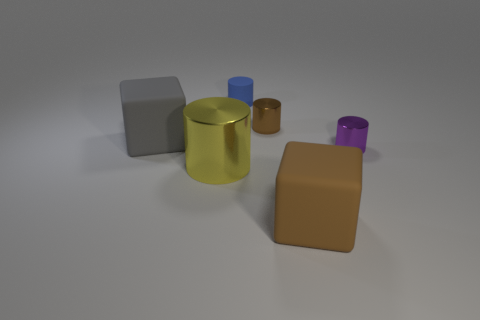Do the small rubber cylinder and the large metal thing have the same color?
Offer a very short reply. No. The metal cylinder that is both right of the tiny blue matte object and on the left side of the purple cylinder is what color?
Your answer should be compact. Brown. How many objects are either small cylinders on the right side of the small blue thing or red shiny spheres?
Offer a very short reply. 2. The matte thing that is the same shape as the yellow shiny thing is what color?
Provide a succinct answer. Blue. Is the shape of the big yellow metallic object the same as the large object that is to the right of the big yellow thing?
Your answer should be compact. No. What number of objects are either big blocks on the right side of the blue rubber object or matte objects that are on the left side of the yellow thing?
Your answer should be very brief. 2. Is the number of brown shiny cylinders right of the large brown thing less than the number of big metal things?
Give a very brief answer. Yes. Is the material of the brown cylinder the same as the tiny cylinder in front of the gray rubber cube?
Your answer should be very brief. Yes. What is the small purple thing made of?
Ensure brevity in your answer.  Metal. There is a big block left of the small blue thing that is behind the block that is right of the small blue object; what is it made of?
Offer a terse response. Rubber. 